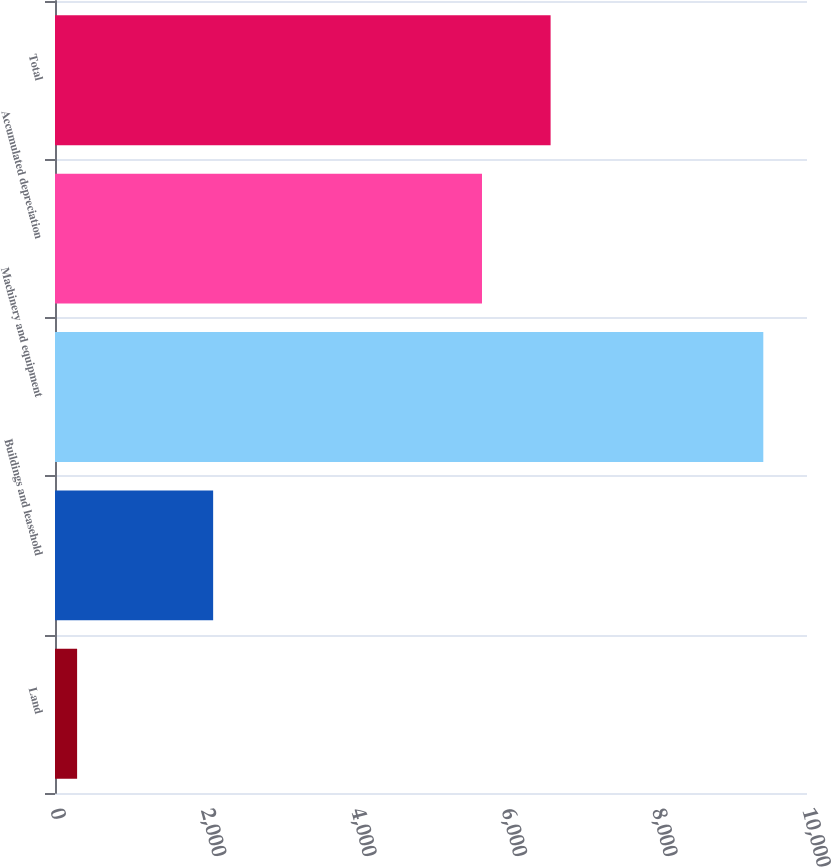Convert chart. <chart><loc_0><loc_0><loc_500><loc_500><bar_chart><fcel>Land<fcel>Buildings and leasehold<fcel>Machinery and equipment<fcel>Accumulated depreciation<fcel>Total<nl><fcel>294<fcel>2103<fcel>9419<fcel>5678<fcel>6590.5<nl></chart> 